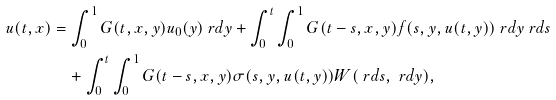<formula> <loc_0><loc_0><loc_500><loc_500>u ( t , x ) & = \int _ { 0 } ^ { 1 } G ( t , x , y ) u _ { 0 } ( y ) \ r d y + \int _ { 0 } ^ { t } \int _ { 0 } ^ { 1 } G ( t - s , x , y ) f ( s , y , u ( t , y ) ) \ r d y \ r d s \\ & \quad + \int _ { 0 } ^ { t } \int _ { 0 } ^ { 1 } G ( t - s , x , y ) \sigma ( s , y , u ( t , y ) ) W ( \ r d s , \ r d y ) ,</formula> 